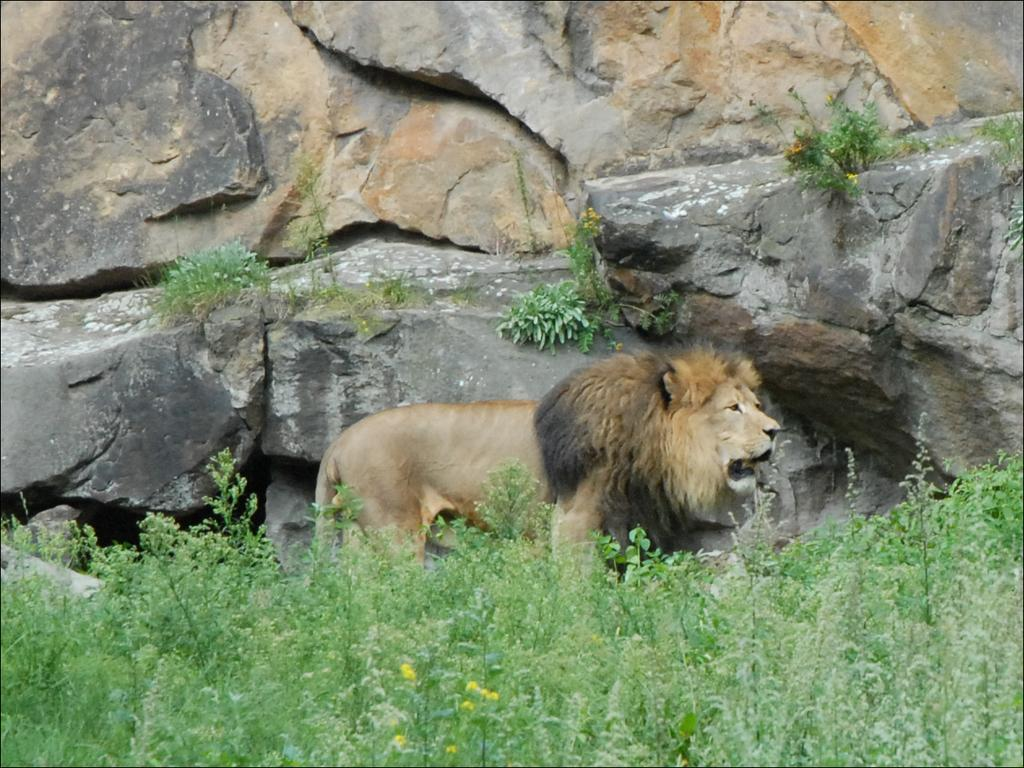What animal is the main subject of the image? There is a lion in the image. What type of vegetation can be seen at the bottom of the image? There are plants at the bottom of the image. What geological features are visible in the background of the image? There are rocks visible in the background of the image. What type of rifle is the lion holding in the image? There is no rifle present in the image; the lion is not holding any object. 